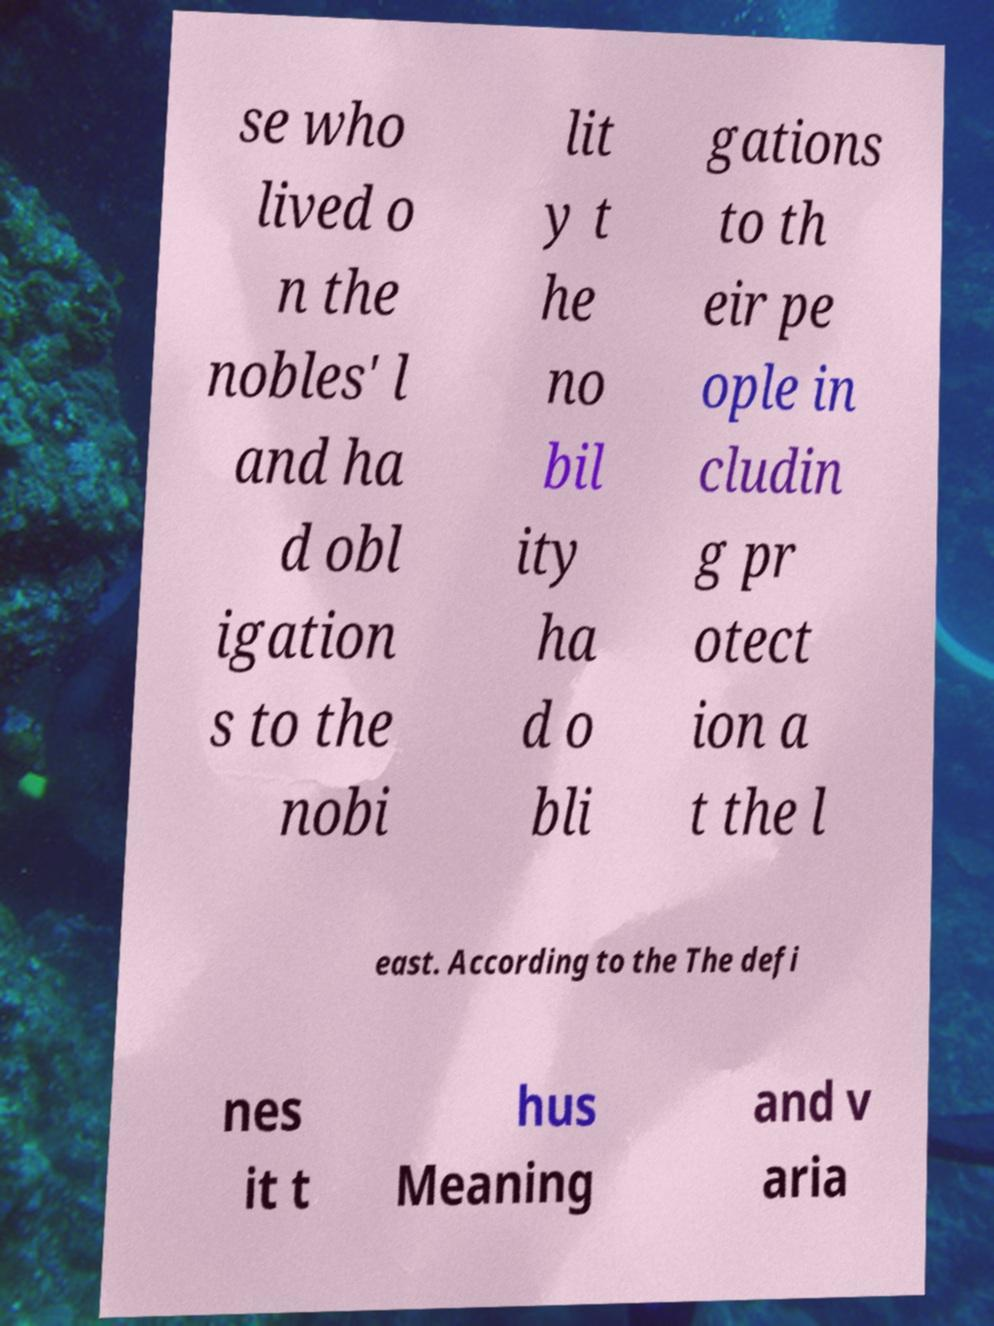There's text embedded in this image that I need extracted. Can you transcribe it verbatim? se who lived o n the nobles' l and ha d obl igation s to the nobi lit y t he no bil ity ha d o bli gations to th eir pe ople in cludin g pr otect ion a t the l east. According to the The defi nes it t hus Meaning and v aria 